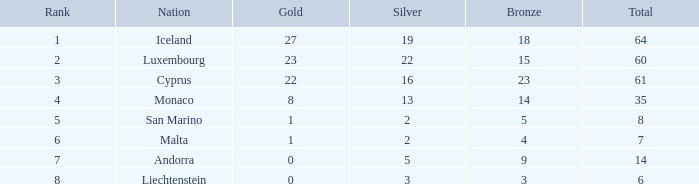For the nation that has 14 medals in total, how many are gold? 0.0. 